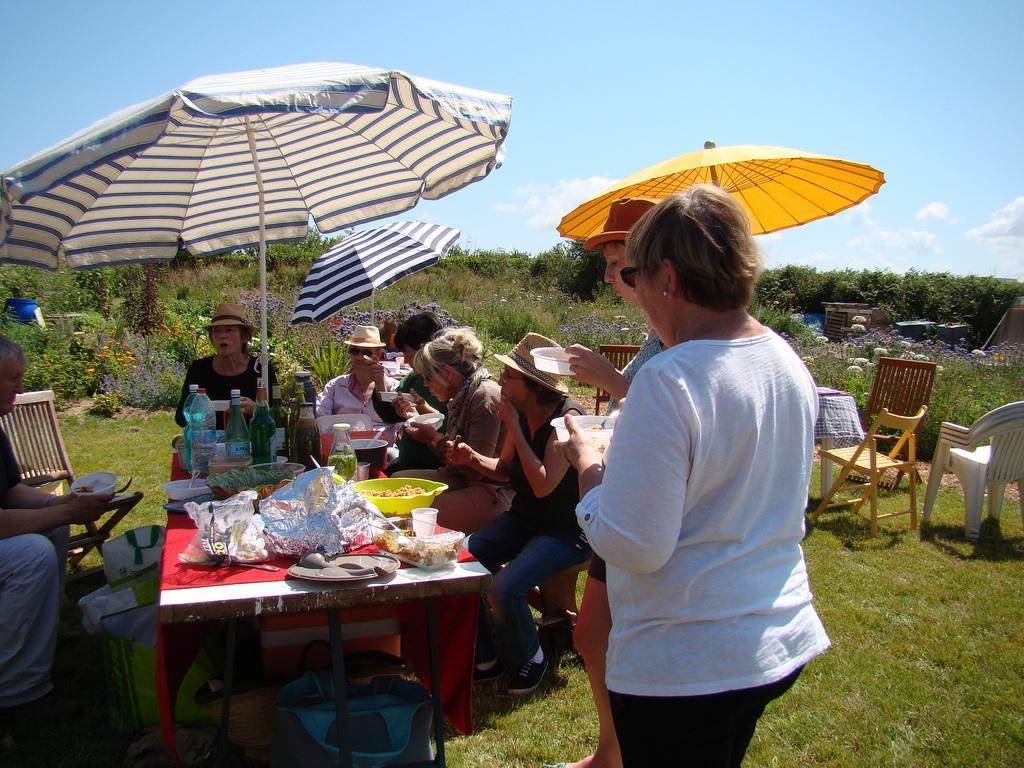Could you give a brief overview of what you see in this image? In the foreground of the picture there are people, chairs, tables, umbrellas, people, food items, grass and other objects. In the center of the picture there are plants, flowers and trees. At the top there is sky. 